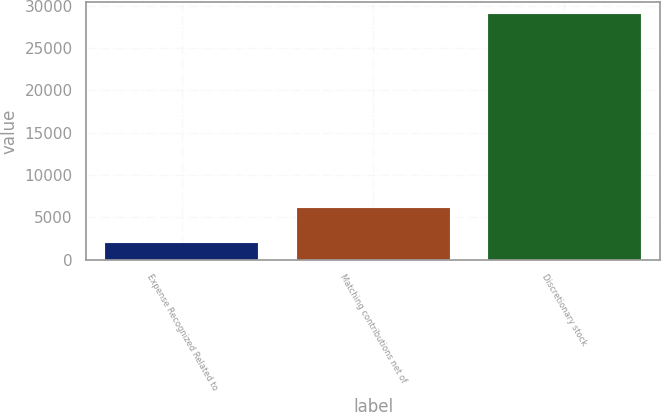Convert chart. <chart><loc_0><loc_0><loc_500><loc_500><bar_chart><fcel>Expense Recognized Related to<fcel>Matching contributions net of<fcel>Discretionary stock<nl><fcel>2009<fcel>6116<fcel>29004<nl></chart> 